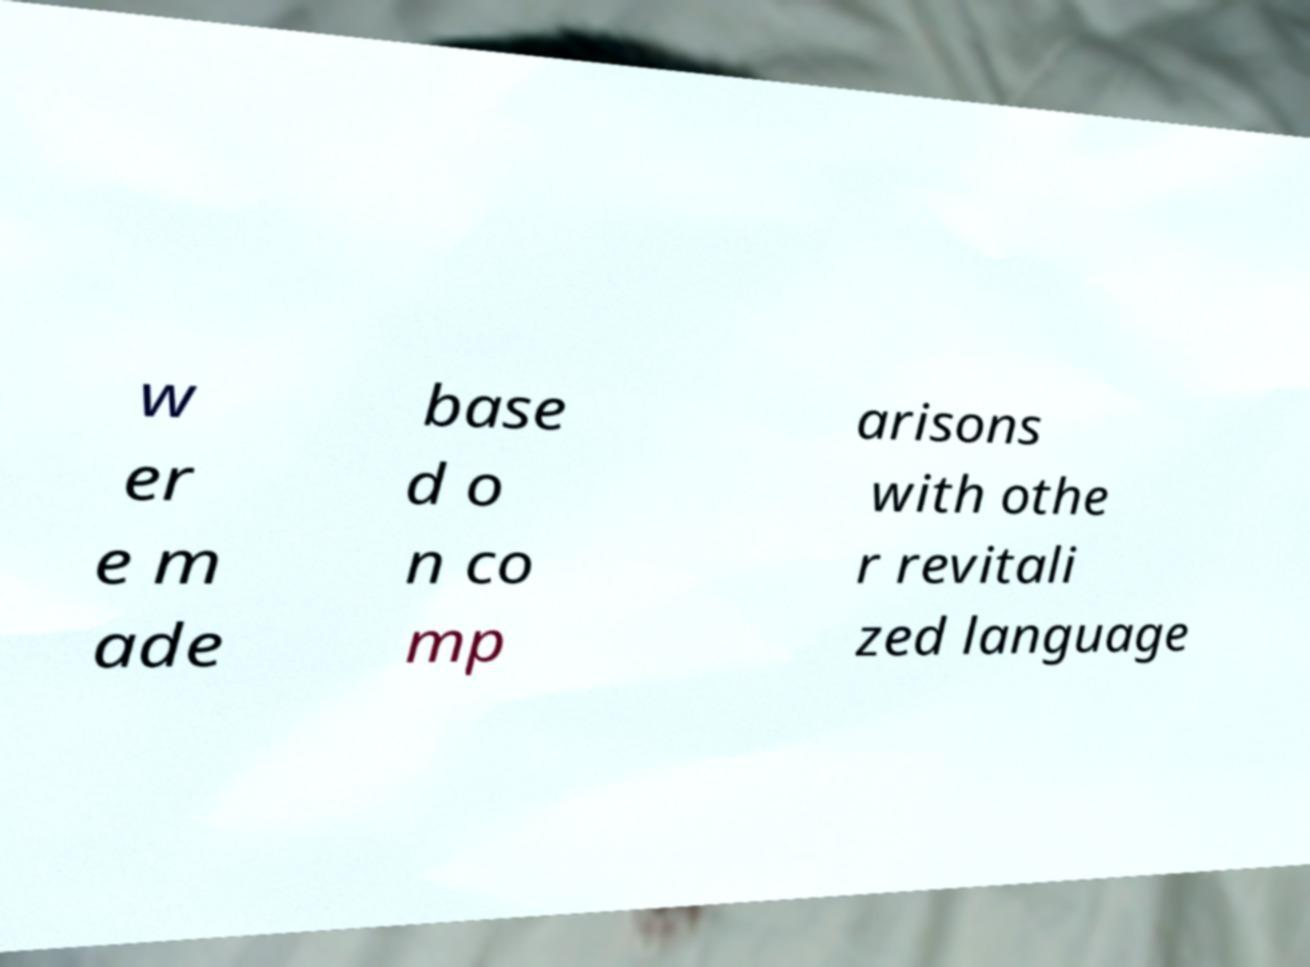Could you assist in decoding the text presented in this image and type it out clearly? w er e m ade base d o n co mp arisons with othe r revitali zed language 